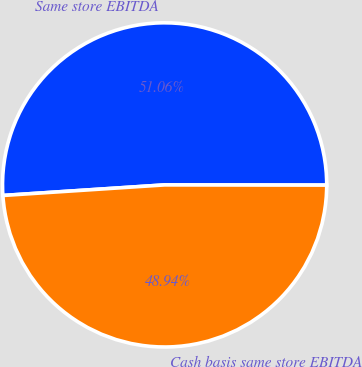Convert chart. <chart><loc_0><loc_0><loc_500><loc_500><pie_chart><fcel>Same store EBITDA<fcel>Cash basis same store EBITDA<nl><fcel>51.06%<fcel>48.94%<nl></chart> 